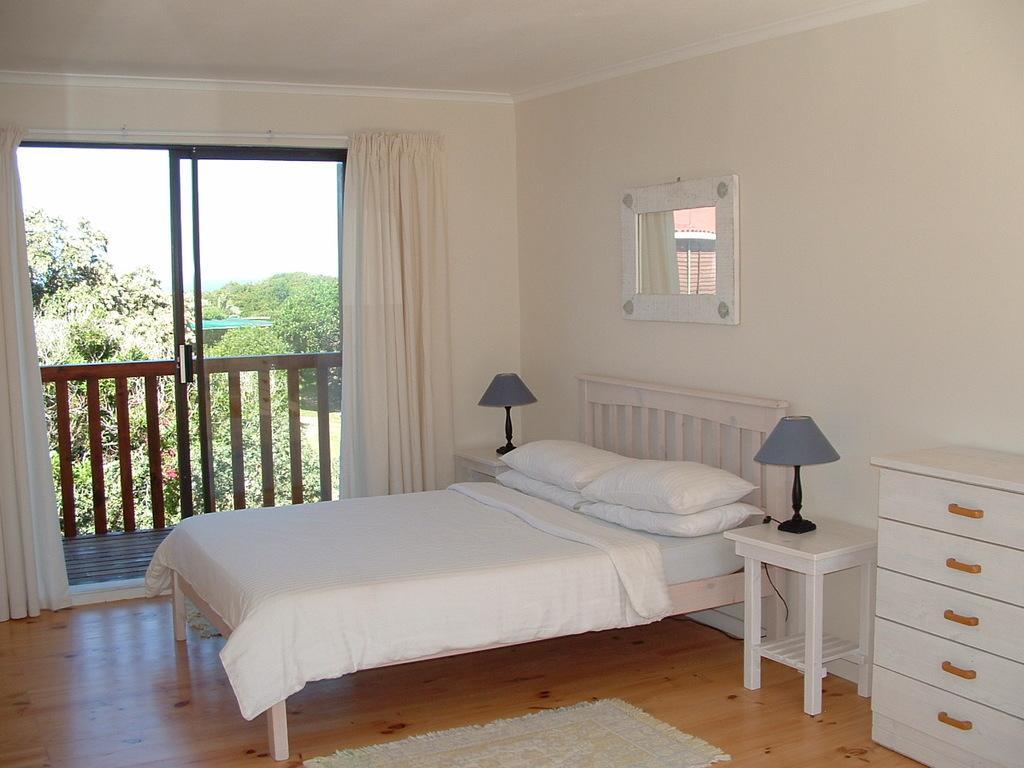Please provide a concise description of this image. This image consists of a bedroom. In that there is a bed, cupboards, lights, mirror, curtain, trees. There is sky at the top. 